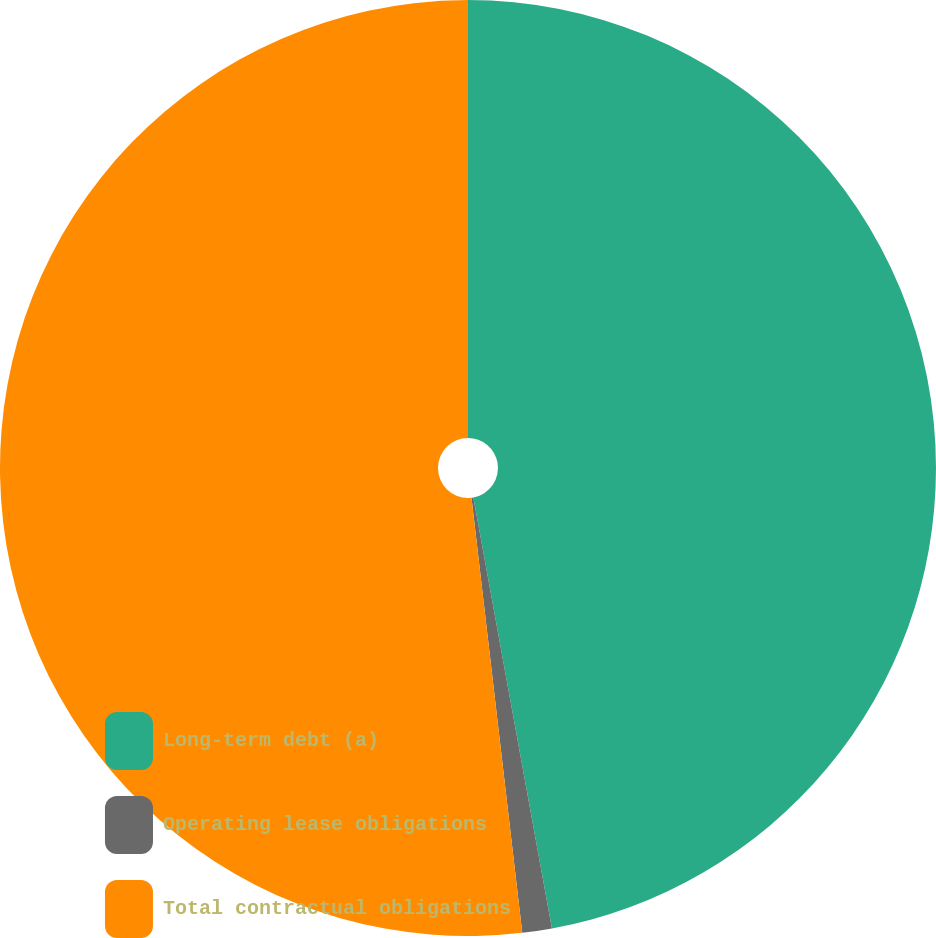Convert chart. <chart><loc_0><loc_0><loc_500><loc_500><pie_chart><fcel>Long-term debt (a)<fcel>Operating lease obligations<fcel>Total contractual obligations<nl><fcel>47.13%<fcel>1.02%<fcel>51.85%<nl></chart> 